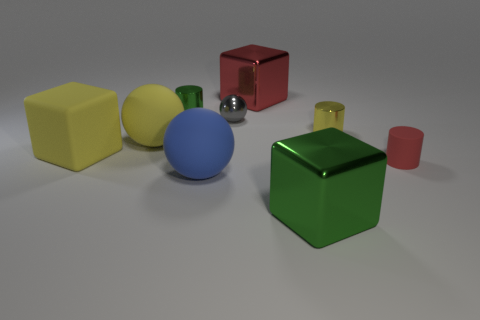There is a object that is behind the small green object; what is its shape? cube 